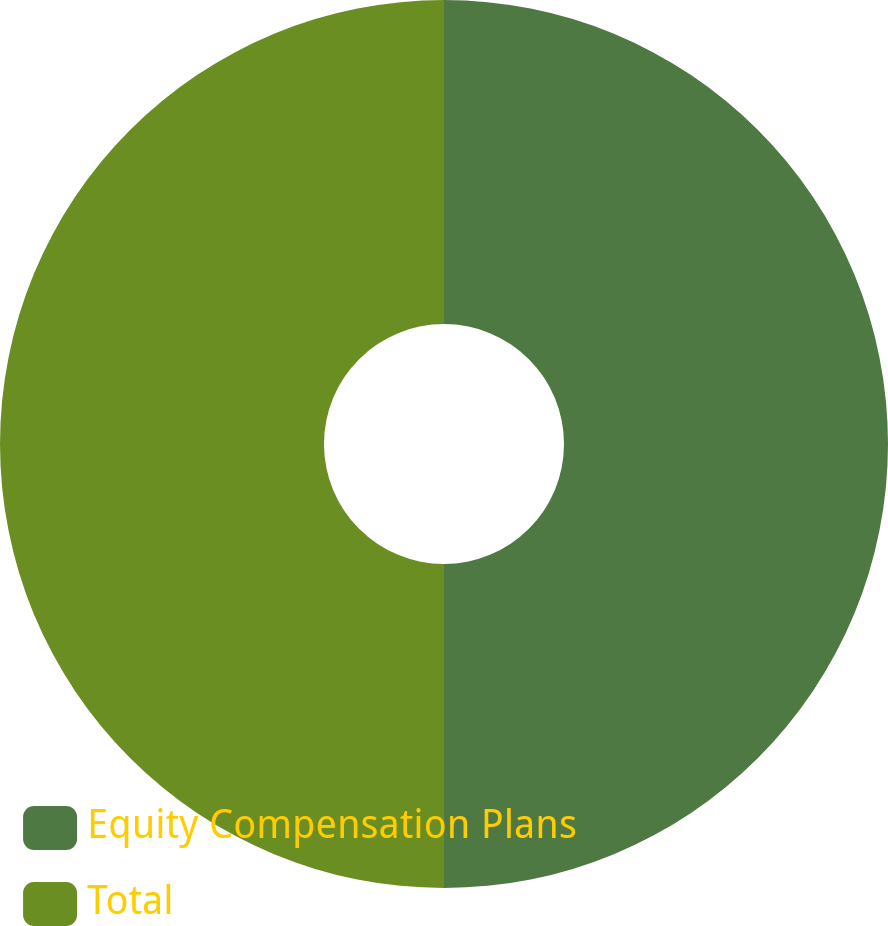Convert chart to OTSL. <chart><loc_0><loc_0><loc_500><loc_500><pie_chart><fcel>Equity Compensation Plans<fcel>Total<nl><fcel>50.0%<fcel>50.0%<nl></chart> 